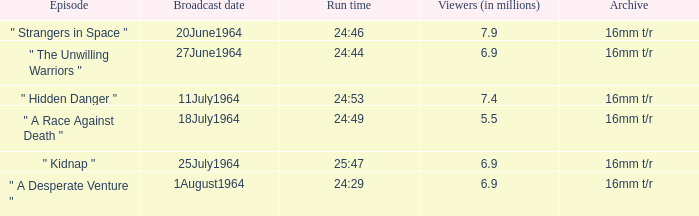What is run time when there were 7.4 million viewers? 24:53. 